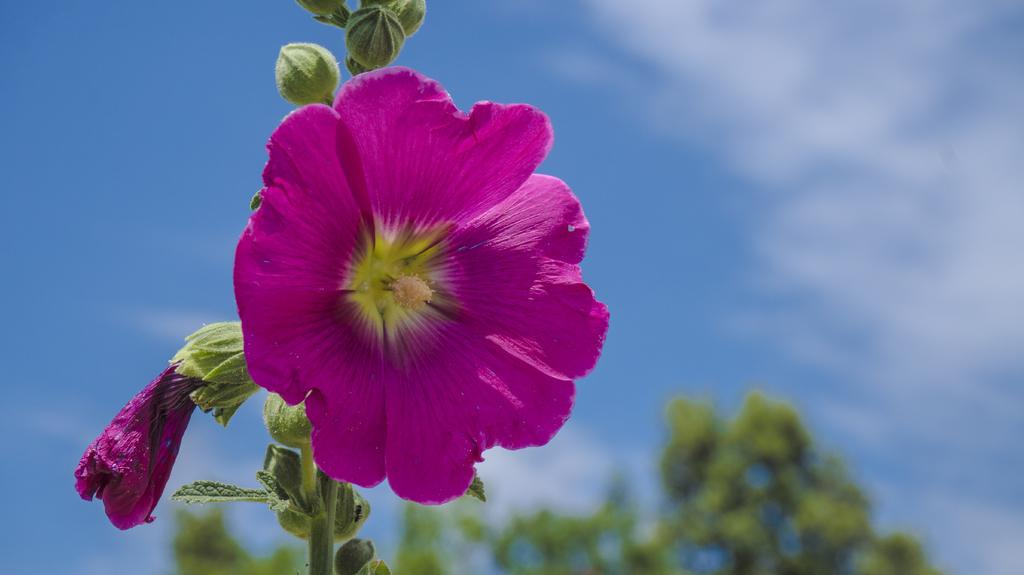What is the person in the image holding? The person is holding a book. What is the state of the book in the image? The book is open. What type of appliance is the person using to cook a meal in the image? There is no appliance or meal present in the image; it only features a person holding an open book. 